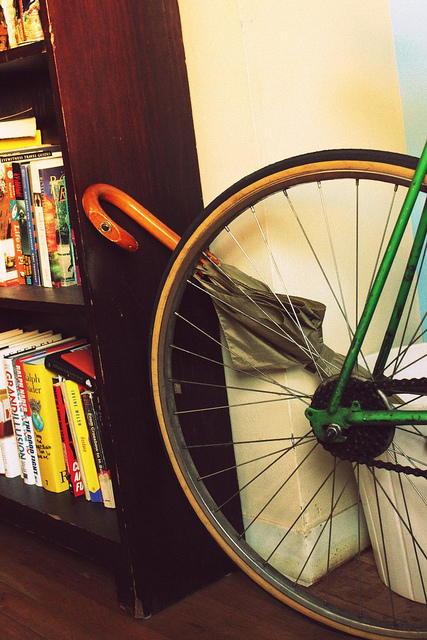How many books can you see? I can see approximately 19 books of various sizes and colors on the bookshelf. The titles are not fully visible, but they look like a mix of novels and non-fiction, reflecting a diverse collection. 